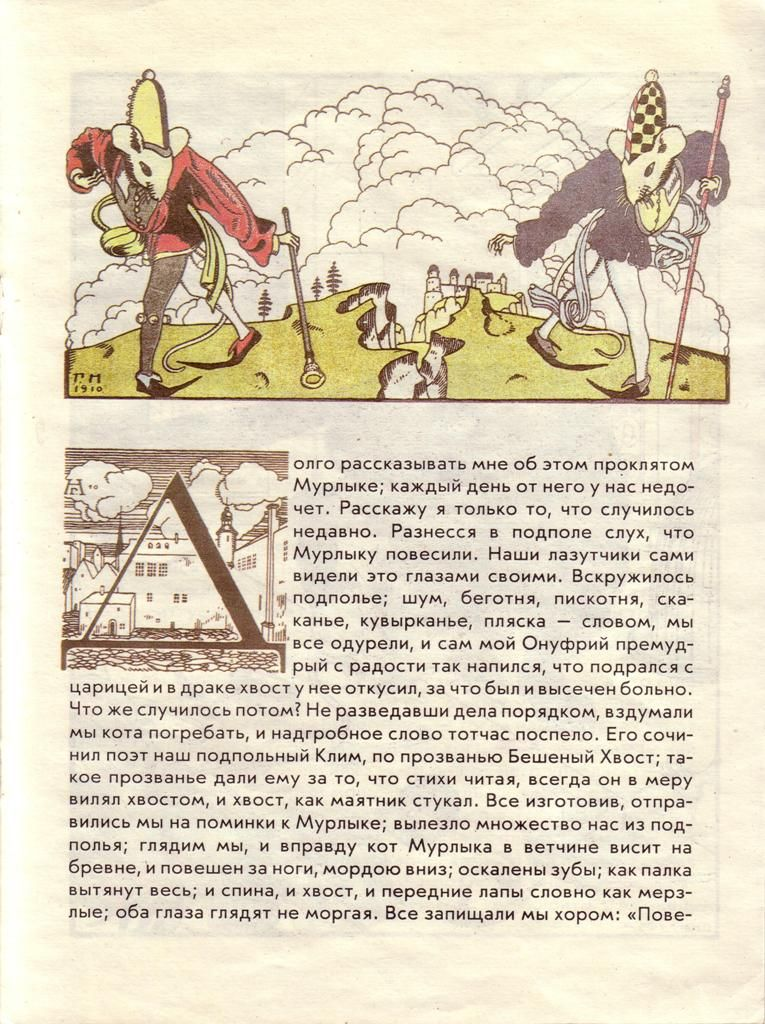Can you describe the artistic influences and possible time period of the artwork? This illustration draws heavily on a blend of medieval and renaissance artistic styles, though interpreted through a clearly modern, whimsical lens. The attire and armor reflect a historical pastiche, not specific to a precise time period but indicative of a general 'medieval' aesthetic. The use of clear, bold lines and bright, contrasting colors aligns more closely with modern graphic styles than with period-accurate depictions, suggesting that the artist was likely working in the 20th or 21st century and engaging with historical themes in a playful, accessible manner. 